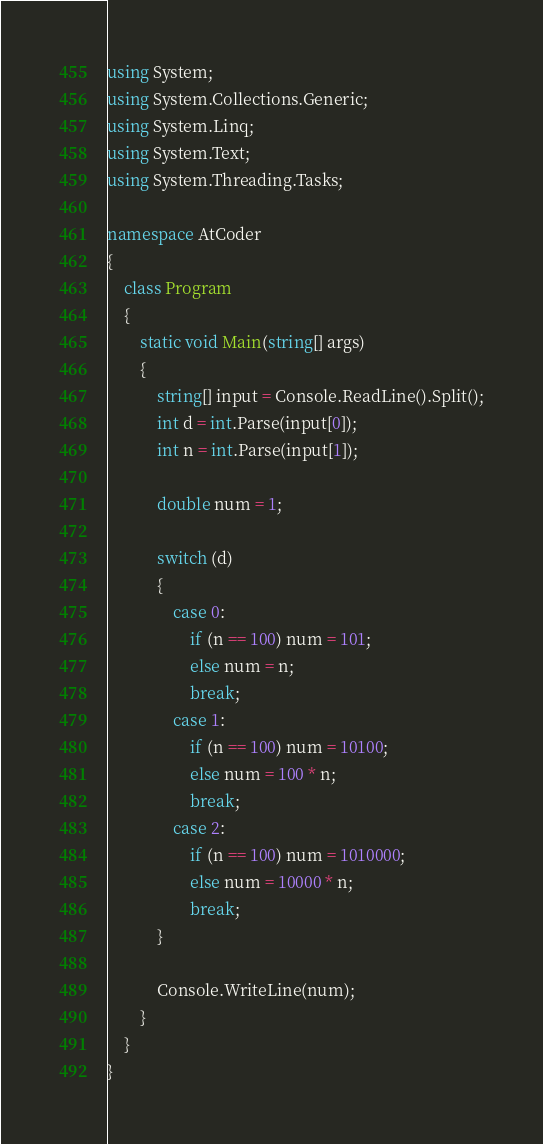<code> <loc_0><loc_0><loc_500><loc_500><_C#_>using System;
using System.Collections.Generic;
using System.Linq;
using System.Text;
using System.Threading.Tasks;

namespace AtCoder
{
    class Program
    {
        static void Main(string[] args)
        {
            string[] input = Console.ReadLine().Split();
            int d = int.Parse(input[0]);
            int n = int.Parse(input[1]);

            double num = 1;

            switch (d)
            {
                case 0:
                    if (n == 100) num = 101;
                    else num = n;
                    break;
                case 1:
                    if (n == 100) num = 10100;
                    else num = 100 * n;
                    break;
                case 2:
                    if (n == 100) num = 1010000;
                    else num = 10000 * n;
                    break;
            }

            Console.WriteLine(num);
        }
    }
}</code> 